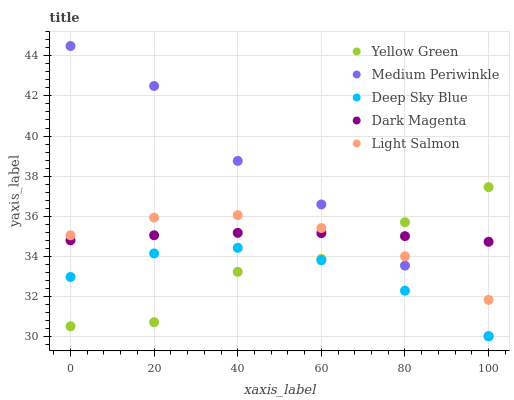Does Deep Sky Blue have the minimum area under the curve?
Answer yes or no. Yes. Does Medium Periwinkle have the maximum area under the curve?
Answer yes or no. Yes. Does Yellow Green have the minimum area under the curve?
Answer yes or no. No. Does Yellow Green have the maximum area under the curve?
Answer yes or no. No. Is Dark Magenta the smoothest?
Answer yes or no. Yes. Is Yellow Green the roughest?
Answer yes or no. Yes. Is Medium Periwinkle the smoothest?
Answer yes or no. No. Is Medium Periwinkle the roughest?
Answer yes or no. No. Does Medium Periwinkle have the lowest value?
Answer yes or no. Yes. Does Yellow Green have the lowest value?
Answer yes or no. No. Does Medium Periwinkle have the highest value?
Answer yes or no. Yes. Does Yellow Green have the highest value?
Answer yes or no. No. Is Deep Sky Blue less than Dark Magenta?
Answer yes or no. Yes. Is Dark Magenta greater than Deep Sky Blue?
Answer yes or no. Yes. Does Medium Periwinkle intersect Deep Sky Blue?
Answer yes or no. Yes. Is Medium Periwinkle less than Deep Sky Blue?
Answer yes or no. No. Is Medium Periwinkle greater than Deep Sky Blue?
Answer yes or no. No. Does Deep Sky Blue intersect Dark Magenta?
Answer yes or no. No. 